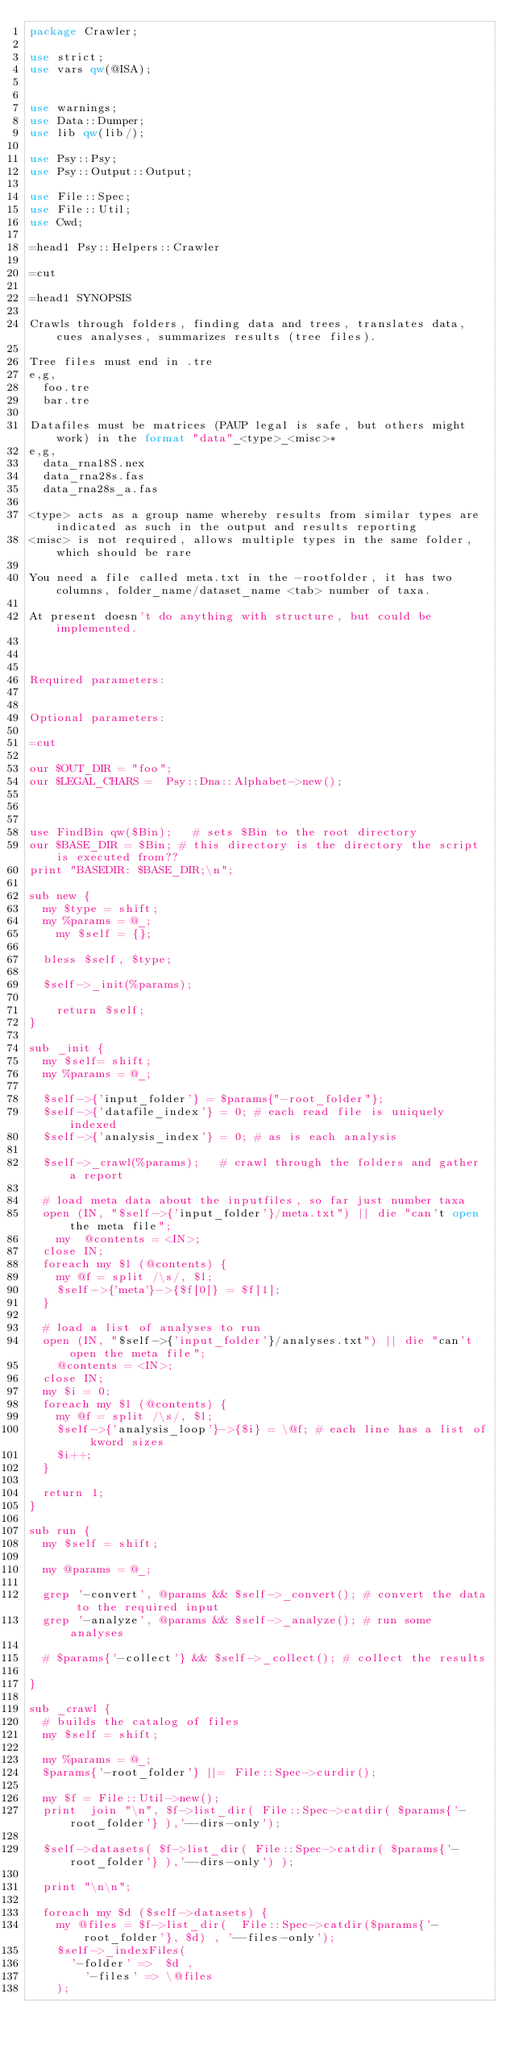<code> <loc_0><loc_0><loc_500><loc_500><_Perl_>package Crawler;

use strict;
use vars qw(@ISA);


use warnings;
use Data::Dumper;	
use lib qw(lib/);

use Psy::Psy;
use Psy::Output::Output;

use File::Spec;
use File::Util;
use Cwd;

=head1 Psy::Helpers::Crawler

=cut

=head1 SYNOPSIS

Crawls through folders, finding data and trees, translates data, cues analyses, summarizes results (tree files).

Tree files must end in .tre
e,g, 
	foo.tre
	bar.tre

Datafiles must be matrices (PAUP legal is safe, but others might work) in the format "data"_<type>_<misc>*
e,g,
	data_rna18S.nex
	data_rna28s.fas
	data_rna28s_a.fas

<type> acts as a group name whereby results from similar types are indicated as such in the output and results reporting
<misc> is not required, allows multiple types in the same folder, which should be rare

You need a file called meta.txt in the -rootfolder, it has two columns, folder_name/dataset_name <tab> number of taxa.

At present doesn't do anything with structure, but could be implemented. 



Required parameters:
	

Optional parameters:

=cut

our $OUT_DIR = "foo";
our $LEGAL_CHARS =  Psy::Dna::Alphabet->new(); 



use FindBin qw($Bin);		# sets $Bin to the root directory
our $BASE_DIR = $Bin;	# this directory is the directory the script is executed from??
print "BASEDIR: $BASE_DIR;\n";

sub new {
	my $type = shift;
	my %params = @_;	
  	my $self = {};
	
	bless $self, $type;

	$self->_init(%params);

    return $self;                 
}

sub _init {
	my $self= shift;
	my %params = @_;

	$self->{'input_folder'} = $params{"-root_folder"};
	$self->{'datafile_index'} = 0; # each read file is uniquely indexed
	$self->{'analysis_index'} = 0; # as is each analysis
	
	$self->_crawl(%params);   # crawl through the folders and gather a report
 
	# load meta data about the inputfiles, so far just number taxa
	open (IN, "$self->{'input_folder'}/meta.txt") || die "can't open the meta file";
		my	@contents = <IN>;
	close IN;
	foreach my $l (@contents) {
		my @f = split /\s/, $l;
		$self->{'meta'}->{$f[0]} = $f[1];
	}

	# load a list of analyses to run
	open (IN, "$self->{'input_folder'}/analyses.txt") || die "can't open the meta file";
		@contents = <IN>;
	close IN;
	my $i = 0;
	foreach my $l (@contents) {
		my @f = split /\s/, $l;
		$self->{'analysis_loop'}->{$i} = \@f; # each line has a list of kword sizes
		$i++;
	}

	return 1;
}

sub run {
	my $self = shift;
	
	my @params = @_;	

	grep '-convert', @params && $self->_convert(); # convert the data to the required input
	grep '-analyze', @params && $self->_analyze(); # run some analyses

	#	$params{'-collect'} && $self->_collect(); # collect the results

}

sub _crawl {
	# builds the catalog of files
	my $self = shift;
	
	my %params = @_;	
	$params{'-root_folder'} ||= File::Spec->curdir();
	
	my $f = File::Util->new();
	print  join "\n", $f->list_dir( File::Spec->catdir( $params{'-root_folder'} ),'--dirs-only');
	
	$self->datasets( $f->list_dir( File::Spec->catdir( $params{'-root_folder'} ),'--dirs-only') );
	
	print "\n\n";
	
	foreach my $d ($self->datasets) {
		my @files = $f->list_dir(  File::Spec->catdir($params{'-root_folder'}, $d) , '--files-only');
		$self->_indexFiles(
			'-folder' =>  $d ,
		    '-files' => \@files
		);</code> 